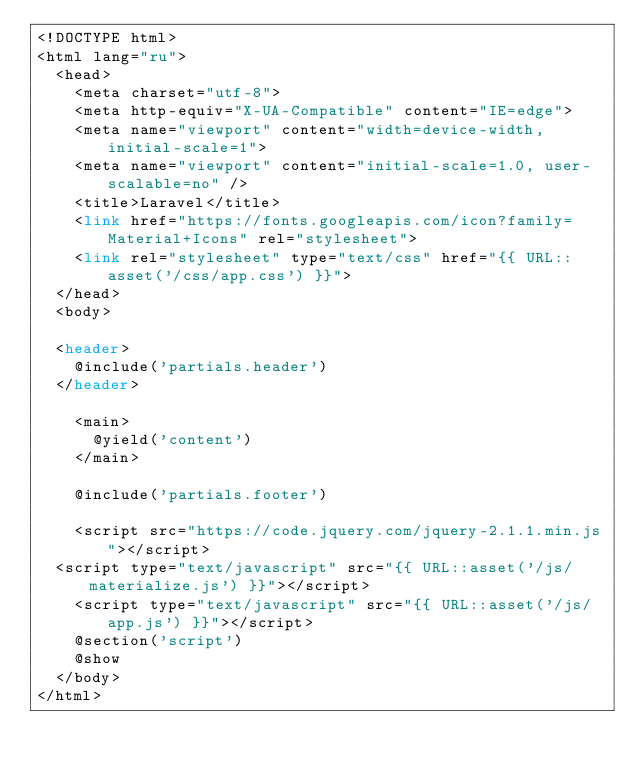<code> <loc_0><loc_0><loc_500><loc_500><_PHP_><!DOCTYPE html>
<html lang="ru">
  <head>
    <meta charset="utf-8">
    <meta http-equiv="X-UA-Compatible" content="IE=edge">
    <meta name="viewport" content="width=device-width, initial-scale=1">
    <meta name="viewport" content="initial-scale=1.0, user-scalable=no" />
    <title>Laravel</title>
    <link href="https://fonts.googleapis.com/icon?family=Material+Icons" rel="stylesheet">
    <link rel="stylesheet" type="text/css" href="{{ URL::asset('/css/app.css') }}">
  </head>
  <body>
	
  <header>
		@include('partials.header')
	</header>

    <main>
    	@yield('content')
    </main>

    @include('partials.footer')
  
    <script src="https://code.jquery.com/jquery-2.1.1.min.js"></script>
	<script type="text/javascript" src="{{ URL::asset('/js/materialize.js') }}"></script>
    <script type="text/javascript" src="{{ URL::asset('/js/app.js') }}"></script>
    @section('script')
    @show
  </body>
</html></code> 